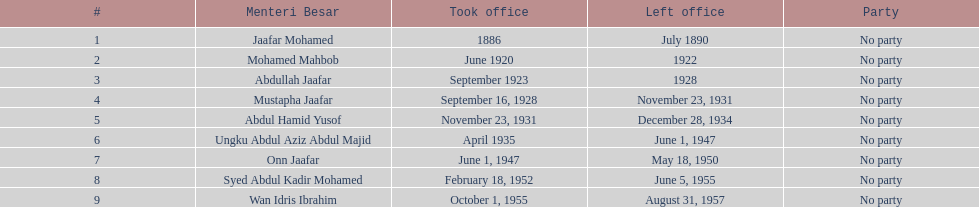Who succeeded onn jaafar in office? Syed Abdul Kadir Mohamed. 